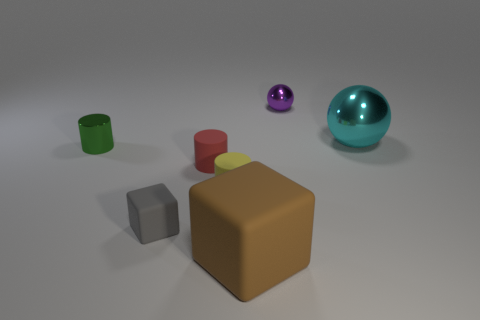How many purple metallic objects are the same shape as the tiny red matte thing?
Your response must be concise. 0. Is the purple sphere made of the same material as the yellow cylinder?
Offer a very short reply. No. What shape is the shiny thing on the left side of the large thing that is in front of the red matte object?
Make the answer very short. Cylinder. How many big cyan shiny things are behind the small yellow rubber cylinder in front of the metal cylinder?
Offer a very short reply. 1. There is a small object that is on the left side of the small red cylinder and behind the gray object; what is its material?
Offer a very short reply. Metal. The gray rubber object that is the same size as the yellow cylinder is what shape?
Your response must be concise. Cube. There is a small shiny thing that is to the left of the rubber cube to the left of the big object in front of the metal cylinder; what is its color?
Give a very brief answer. Green. What number of objects are either things that are in front of the large shiny sphere or purple shiny things?
Give a very brief answer. 6. There is a green thing that is the same size as the purple ball; what is it made of?
Your answer should be very brief. Metal. What is the material of the large object to the left of the small shiny object behind the tiny metallic thing on the left side of the large brown rubber object?
Ensure brevity in your answer.  Rubber. 